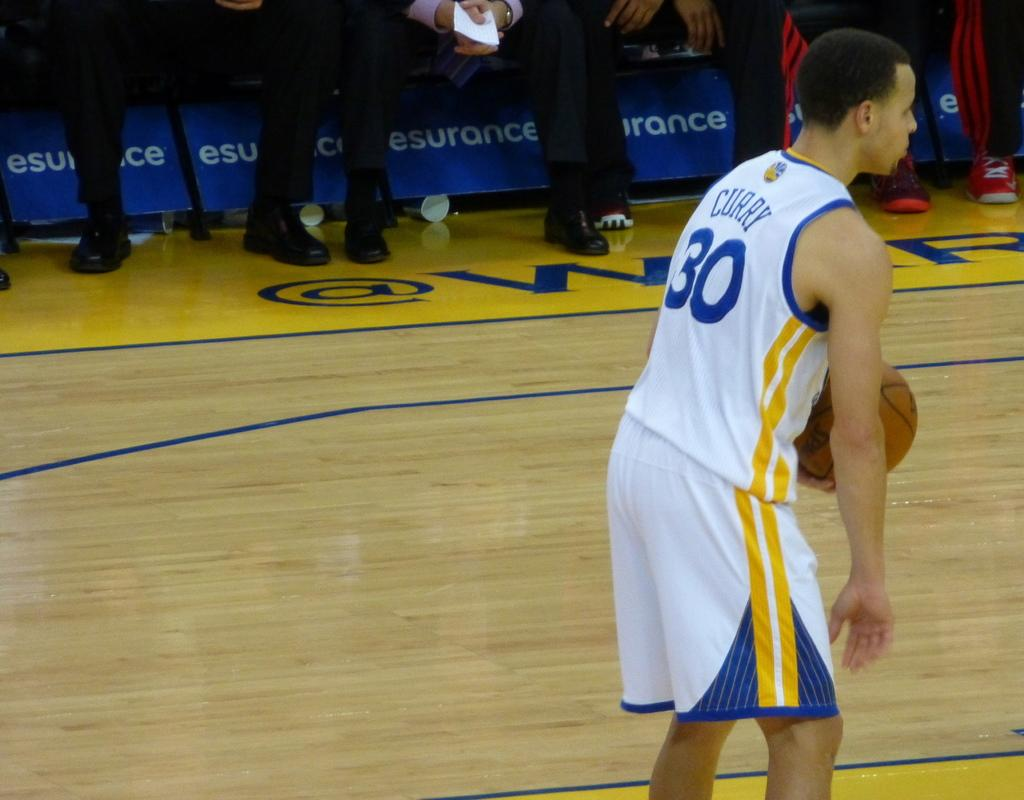<image>
Create a compact narrative representing the image presented. A basketball player named Curry wears the number 30 uniform. 